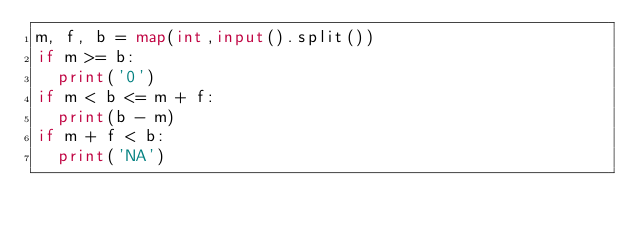<code> <loc_0><loc_0><loc_500><loc_500><_Python_>m, f, b = map(int,input().split())
if m >= b:
  print('0')
if m < b <= m + f:
  print(b - m)  
if m + f < b:
  print('NA')
</code> 